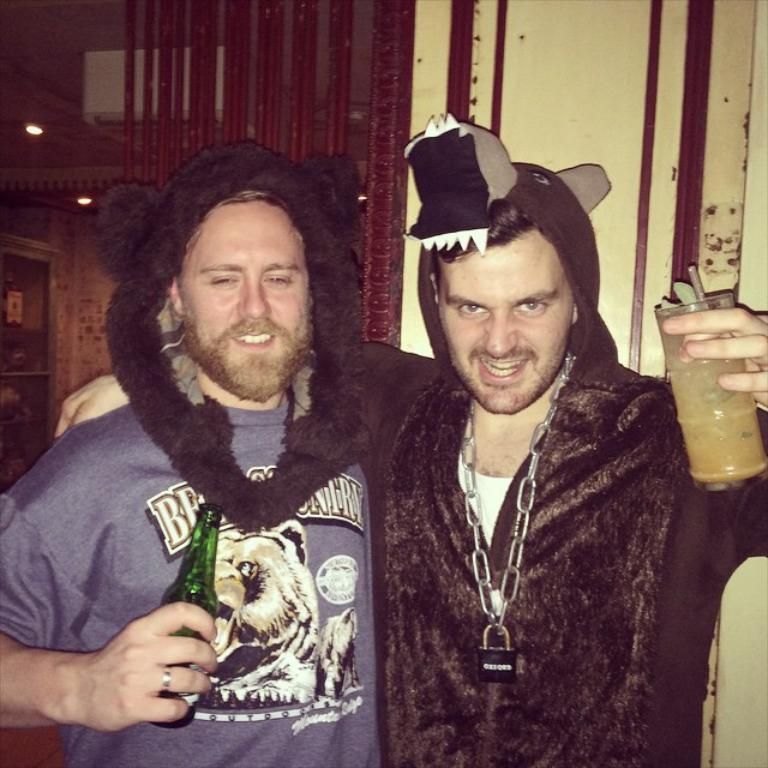How many people are in the image? There are two men in the image. What are the men holding in their hands? One man is holding a drink bottle, and the other man is holding a glass with a drink in it. What can be seen in the background of the image? There is a wall in the background of the image. What type of peace symbol can be seen on the stranger's shirt in the image? There is no stranger or peace symbol present in the image; it features two men holding drinks. Can you describe the rod that the creature is holding in the image? There is no creature or rod present in the image. 